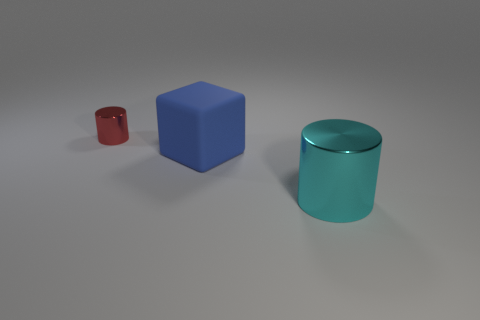Considering the size difference between the objects, could this represent something from real life? The objects in the image, while differing in size, could be seen as a stylized representation of real life, where objects of various sizes coexist. The size difference could also metaphorically represent the concept of scale or importance, where the larger object dominates the visual field. If these objects had distinctive textures, what could they be to make this scene more realistic? If the objects had more distinctive textures, the small cylinder could have a metallic or matte finish to suggest utility, the blue block a rough, opaque surface to enhance its tangible quality, and the large clear object could exhibit subtle imperfections or frosted areas to suggest glass or transparent plastic. 